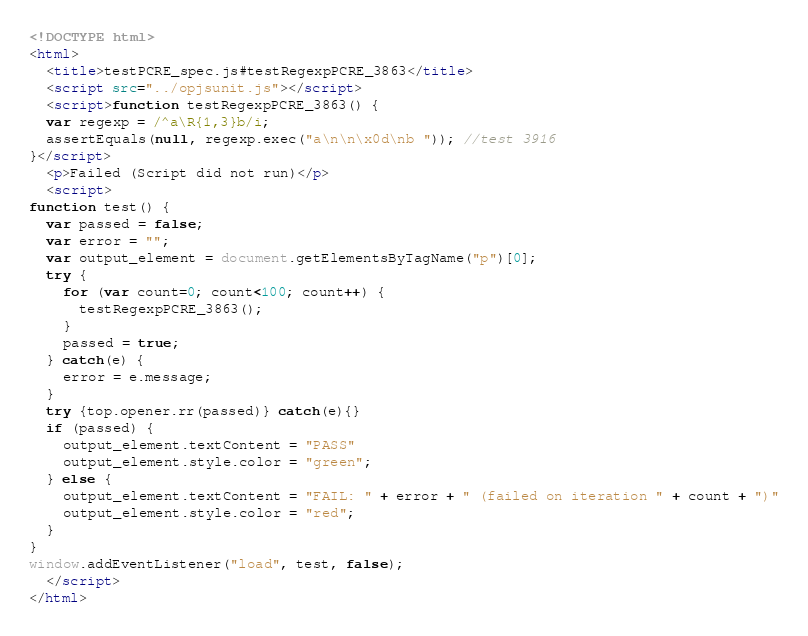Convert code to text. <code><loc_0><loc_0><loc_500><loc_500><_HTML_><!DOCTYPE html>
<html>
  <title>testPCRE_spec.js#testRegexpPCRE_3863</title>
  <script src="../opjsunit.js"></script>
  <script>function testRegexpPCRE_3863() {
  var regexp = /^a\R{1,3}b/i;
  assertEquals(null, regexp.exec("a\n\n\x0d\nb ")); //test 3916
}</script>
  <p>Failed (Script did not run)</p>
  <script>
function test() {
  var passed = false;
  var error = "";
  var output_element = document.getElementsByTagName("p")[0];
  try {
    for (var count=0; count<100; count++) {
      testRegexpPCRE_3863();
    }
    passed = true;
  } catch(e) {
    error = e.message;
  }
  try {top.opener.rr(passed)} catch(e){}
  if (passed) {
    output_element.textContent = "PASS"
    output_element.style.color = "green";
  } else {
    output_element.textContent = "FAIL: " + error + " (failed on iteration " + count + ")"
    output_element.style.color = "red";
  }
}
window.addEventListener("load", test, false);
  </script>
</html></code> 